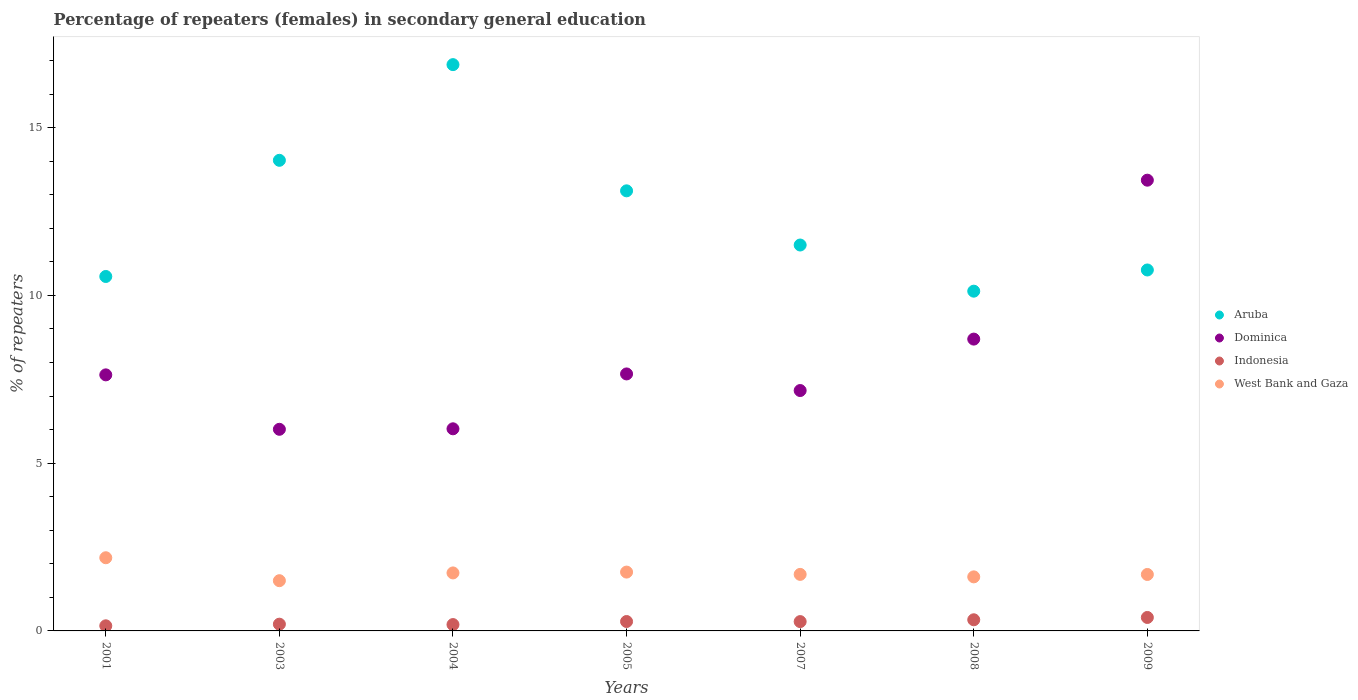Is the number of dotlines equal to the number of legend labels?
Keep it short and to the point. Yes. What is the percentage of female repeaters in West Bank and Gaza in 2001?
Your answer should be very brief. 2.18. Across all years, what is the maximum percentage of female repeaters in Aruba?
Keep it short and to the point. 16.88. Across all years, what is the minimum percentage of female repeaters in Indonesia?
Ensure brevity in your answer.  0.15. In which year was the percentage of female repeaters in West Bank and Gaza maximum?
Provide a succinct answer. 2001. What is the total percentage of female repeaters in Indonesia in the graph?
Give a very brief answer. 1.83. What is the difference between the percentage of female repeaters in Indonesia in 2004 and that in 2009?
Keep it short and to the point. -0.21. What is the difference between the percentage of female repeaters in Indonesia in 2004 and the percentage of female repeaters in Aruba in 2005?
Offer a very short reply. -12.93. What is the average percentage of female repeaters in Dominica per year?
Provide a succinct answer. 8.09. In the year 2009, what is the difference between the percentage of female repeaters in Dominica and percentage of female repeaters in West Bank and Gaza?
Offer a terse response. 11.75. What is the ratio of the percentage of female repeaters in West Bank and Gaza in 2005 to that in 2008?
Ensure brevity in your answer.  1.09. What is the difference between the highest and the second highest percentage of female repeaters in West Bank and Gaza?
Your answer should be compact. 0.43. What is the difference between the highest and the lowest percentage of female repeaters in Indonesia?
Keep it short and to the point. 0.25. Is the sum of the percentage of female repeaters in Indonesia in 2001 and 2003 greater than the maximum percentage of female repeaters in Dominica across all years?
Give a very brief answer. No. Does the percentage of female repeaters in Indonesia monotonically increase over the years?
Provide a succinct answer. No. Is the percentage of female repeaters in Indonesia strictly greater than the percentage of female repeaters in Dominica over the years?
Keep it short and to the point. No. How are the legend labels stacked?
Provide a short and direct response. Vertical. What is the title of the graph?
Your answer should be compact. Percentage of repeaters (females) in secondary general education. What is the label or title of the X-axis?
Keep it short and to the point. Years. What is the label or title of the Y-axis?
Ensure brevity in your answer.  % of repeaters. What is the % of repeaters of Aruba in 2001?
Ensure brevity in your answer.  10.56. What is the % of repeaters in Dominica in 2001?
Offer a very short reply. 7.63. What is the % of repeaters of Indonesia in 2001?
Offer a very short reply. 0.15. What is the % of repeaters of West Bank and Gaza in 2001?
Give a very brief answer. 2.18. What is the % of repeaters of Aruba in 2003?
Your response must be concise. 14.03. What is the % of repeaters in Dominica in 2003?
Provide a succinct answer. 6.01. What is the % of repeaters of Indonesia in 2003?
Give a very brief answer. 0.2. What is the % of repeaters in West Bank and Gaza in 2003?
Your response must be concise. 1.5. What is the % of repeaters of Aruba in 2004?
Make the answer very short. 16.88. What is the % of repeaters of Dominica in 2004?
Provide a succinct answer. 6.02. What is the % of repeaters of Indonesia in 2004?
Offer a very short reply. 0.19. What is the % of repeaters in West Bank and Gaza in 2004?
Ensure brevity in your answer.  1.73. What is the % of repeaters of Aruba in 2005?
Make the answer very short. 13.12. What is the % of repeaters in Dominica in 2005?
Your answer should be compact. 7.66. What is the % of repeaters in Indonesia in 2005?
Make the answer very short. 0.28. What is the % of repeaters of West Bank and Gaza in 2005?
Provide a short and direct response. 1.75. What is the % of repeaters of Aruba in 2007?
Ensure brevity in your answer.  11.5. What is the % of repeaters of Dominica in 2007?
Provide a succinct answer. 7.17. What is the % of repeaters in Indonesia in 2007?
Ensure brevity in your answer.  0.28. What is the % of repeaters in West Bank and Gaza in 2007?
Ensure brevity in your answer.  1.68. What is the % of repeaters in Aruba in 2008?
Provide a succinct answer. 10.13. What is the % of repeaters in Dominica in 2008?
Provide a short and direct response. 8.7. What is the % of repeaters in Indonesia in 2008?
Offer a very short reply. 0.33. What is the % of repeaters in West Bank and Gaza in 2008?
Ensure brevity in your answer.  1.61. What is the % of repeaters of Aruba in 2009?
Ensure brevity in your answer.  10.76. What is the % of repeaters in Dominica in 2009?
Your answer should be very brief. 13.43. What is the % of repeaters of Indonesia in 2009?
Ensure brevity in your answer.  0.4. What is the % of repeaters in West Bank and Gaza in 2009?
Offer a terse response. 1.68. Across all years, what is the maximum % of repeaters in Aruba?
Offer a very short reply. 16.88. Across all years, what is the maximum % of repeaters in Dominica?
Offer a terse response. 13.43. Across all years, what is the maximum % of repeaters in Indonesia?
Ensure brevity in your answer.  0.4. Across all years, what is the maximum % of repeaters in West Bank and Gaza?
Make the answer very short. 2.18. Across all years, what is the minimum % of repeaters of Aruba?
Provide a short and direct response. 10.13. Across all years, what is the minimum % of repeaters in Dominica?
Provide a short and direct response. 6.01. Across all years, what is the minimum % of repeaters in Indonesia?
Your response must be concise. 0.15. Across all years, what is the minimum % of repeaters of West Bank and Gaza?
Provide a short and direct response. 1.5. What is the total % of repeaters in Aruba in the graph?
Provide a succinct answer. 86.98. What is the total % of repeaters of Dominica in the graph?
Ensure brevity in your answer.  56.62. What is the total % of repeaters in Indonesia in the graph?
Ensure brevity in your answer.  1.83. What is the total % of repeaters in West Bank and Gaza in the graph?
Offer a terse response. 12.14. What is the difference between the % of repeaters in Aruba in 2001 and that in 2003?
Make the answer very short. -3.46. What is the difference between the % of repeaters of Dominica in 2001 and that in 2003?
Ensure brevity in your answer.  1.62. What is the difference between the % of repeaters of Indonesia in 2001 and that in 2003?
Keep it short and to the point. -0.05. What is the difference between the % of repeaters in West Bank and Gaza in 2001 and that in 2003?
Ensure brevity in your answer.  0.68. What is the difference between the % of repeaters of Aruba in 2001 and that in 2004?
Your answer should be compact. -6.31. What is the difference between the % of repeaters of Dominica in 2001 and that in 2004?
Your answer should be compact. 1.61. What is the difference between the % of repeaters in Indonesia in 2001 and that in 2004?
Give a very brief answer. -0.04. What is the difference between the % of repeaters of West Bank and Gaza in 2001 and that in 2004?
Your answer should be compact. 0.45. What is the difference between the % of repeaters of Aruba in 2001 and that in 2005?
Ensure brevity in your answer.  -2.55. What is the difference between the % of repeaters in Dominica in 2001 and that in 2005?
Provide a succinct answer. -0.03. What is the difference between the % of repeaters of Indonesia in 2001 and that in 2005?
Make the answer very short. -0.13. What is the difference between the % of repeaters of West Bank and Gaza in 2001 and that in 2005?
Your response must be concise. 0.43. What is the difference between the % of repeaters in Aruba in 2001 and that in 2007?
Your answer should be compact. -0.94. What is the difference between the % of repeaters of Dominica in 2001 and that in 2007?
Ensure brevity in your answer.  0.47. What is the difference between the % of repeaters of Indonesia in 2001 and that in 2007?
Offer a terse response. -0.13. What is the difference between the % of repeaters in West Bank and Gaza in 2001 and that in 2007?
Your answer should be compact. 0.5. What is the difference between the % of repeaters in Aruba in 2001 and that in 2008?
Provide a succinct answer. 0.44. What is the difference between the % of repeaters of Dominica in 2001 and that in 2008?
Offer a terse response. -1.07. What is the difference between the % of repeaters of Indonesia in 2001 and that in 2008?
Offer a terse response. -0.18. What is the difference between the % of repeaters in West Bank and Gaza in 2001 and that in 2008?
Make the answer very short. 0.57. What is the difference between the % of repeaters in Aruba in 2001 and that in 2009?
Keep it short and to the point. -0.19. What is the difference between the % of repeaters of Dominica in 2001 and that in 2009?
Your answer should be compact. -5.8. What is the difference between the % of repeaters in Indonesia in 2001 and that in 2009?
Provide a short and direct response. -0.25. What is the difference between the % of repeaters of West Bank and Gaza in 2001 and that in 2009?
Your response must be concise. 0.5. What is the difference between the % of repeaters of Aruba in 2003 and that in 2004?
Your answer should be compact. -2.85. What is the difference between the % of repeaters in Dominica in 2003 and that in 2004?
Provide a succinct answer. -0.01. What is the difference between the % of repeaters of Indonesia in 2003 and that in 2004?
Ensure brevity in your answer.  0.01. What is the difference between the % of repeaters of West Bank and Gaza in 2003 and that in 2004?
Your answer should be compact. -0.23. What is the difference between the % of repeaters in Aruba in 2003 and that in 2005?
Ensure brevity in your answer.  0.91. What is the difference between the % of repeaters of Dominica in 2003 and that in 2005?
Provide a succinct answer. -1.65. What is the difference between the % of repeaters in Indonesia in 2003 and that in 2005?
Keep it short and to the point. -0.08. What is the difference between the % of repeaters of West Bank and Gaza in 2003 and that in 2005?
Your answer should be compact. -0.26. What is the difference between the % of repeaters in Aruba in 2003 and that in 2007?
Provide a succinct answer. 2.52. What is the difference between the % of repeaters of Dominica in 2003 and that in 2007?
Give a very brief answer. -1.16. What is the difference between the % of repeaters in Indonesia in 2003 and that in 2007?
Your answer should be compact. -0.08. What is the difference between the % of repeaters of West Bank and Gaza in 2003 and that in 2007?
Your answer should be very brief. -0.19. What is the difference between the % of repeaters of Aruba in 2003 and that in 2008?
Make the answer very short. 3.9. What is the difference between the % of repeaters in Dominica in 2003 and that in 2008?
Your response must be concise. -2.69. What is the difference between the % of repeaters in Indonesia in 2003 and that in 2008?
Your answer should be very brief. -0.13. What is the difference between the % of repeaters of West Bank and Gaza in 2003 and that in 2008?
Your answer should be compact. -0.11. What is the difference between the % of repeaters in Aruba in 2003 and that in 2009?
Ensure brevity in your answer.  3.27. What is the difference between the % of repeaters of Dominica in 2003 and that in 2009?
Your answer should be compact. -7.43. What is the difference between the % of repeaters in Indonesia in 2003 and that in 2009?
Offer a very short reply. -0.2. What is the difference between the % of repeaters of West Bank and Gaza in 2003 and that in 2009?
Provide a succinct answer. -0.19. What is the difference between the % of repeaters of Aruba in 2004 and that in 2005?
Make the answer very short. 3.76. What is the difference between the % of repeaters in Dominica in 2004 and that in 2005?
Your response must be concise. -1.64. What is the difference between the % of repeaters in Indonesia in 2004 and that in 2005?
Offer a very short reply. -0.09. What is the difference between the % of repeaters of West Bank and Gaza in 2004 and that in 2005?
Your response must be concise. -0.03. What is the difference between the % of repeaters of Aruba in 2004 and that in 2007?
Your response must be concise. 5.38. What is the difference between the % of repeaters of Dominica in 2004 and that in 2007?
Your response must be concise. -1.14. What is the difference between the % of repeaters of Indonesia in 2004 and that in 2007?
Keep it short and to the point. -0.09. What is the difference between the % of repeaters in West Bank and Gaza in 2004 and that in 2007?
Your answer should be very brief. 0.04. What is the difference between the % of repeaters of Aruba in 2004 and that in 2008?
Your response must be concise. 6.75. What is the difference between the % of repeaters in Dominica in 2004 and that in 2008?
Ensure brevity in your answer.  -2.67. What is the difference between the % of repeaters in Indonesia in 2004 and that in 2008?
Your answer should be very brief. -0.14. What is the difference between the % of repeaters of West Bank and Gaza in 2004 and that in 2008?
Ensure brevity in your answer.  0.12. What is the difference between the % of repeaters in Aruba in 2004 and that in 2009?
Your answer should be very brief. 6.12. What is the difference between the % of repeaters of Dominica in 2004 and that in 2009?
Offer a very short reply. -7.41. What is the difference between the % of repeaters of Indonesia in 2004 and that in 2009?
Offer a very short reply. -0.21. What is the difference between the % of repeaters of West Bank and Gaza in 2004 and that in 2009?
Ensure brevity in your answer.  0.05. What is the difference between the % of repeaters of Aruba in 2005 and that in 2007?
Keep it short and to the point. 1.61. What is the difference between the % of repeaters in Dominica in 2005 and that in 2007?
Offer a terse response. 0.49. What is the difference between the % of repeaters of Indonesia in 2005 and that in 2007?
Offer a terse response. 0. What is the difference between the % of repeaters in West Bank and Gaza in 2005 and that in 2007?
Provide a succinct answer. 0.07. What is the difference between the % of repeaters in Aruba in 2005 and that in 2008?
Provide a short and direct response. 2.99. What is the difference between the % of repeaters of Dominica in 2005 and that in 2008?
Your answer should be compact. -1.04. What is the difference between the % of repeaters of Indonesia in 2005 and that in 2008?
Offer a terse response. -0.05. What is the difference between the % of repeaters of West Bank and Gaza in 2005 and that in 2008?
Make the answer very short. 0.14. What is the difference between the % of repeaters in Aruba in 2005 and that in 2009?
Make the answer very short. 2.36. What is the difference between the % of repeaters of Dominica in 2005 and that in 2009?
Provide a succinct answer. -5.78. What is the difference between the % of repeaters in Indonesia in 2005 and that in 2009?
Provide a short and direct response. -0.12. What is the difference between the % of repeaters in West Bank and Gaza in 2005 and that in 2009?
Give a very brief answer. 0.07. What is the difference between the % of repeaters in Aruba in 2007 and that in 2008?
Your response must be concise. 1.38. What is the difference between the % of repeaters in Dominica in 2007 and that in 2008?
Ensure brevity in your answer.  -1.53. What is the difference between the % of repeaters of Indonesia in 2007 and that in 2008?
Your response must be concise. -0.05. What is the difference between the % of repeaters in West Bank and Gaza in 2007 and that in 2008?
Give a very brief answer. 0.07. What is the difference between the % of repeaters in Aruba in 2007 and that in 2009?
Provide a succinct answer. 0.74. What is the difference between the % of repeaters in Dominica in 2007 and that in 2009?
Make the answer very short. -6.27. What is the difference between the % of repeaters in Indonesia in 2007 and that in 2009?
Give a very brief answer. -0.12. What is the difference between the % of repeaters of West Bank and Gaza in 2007 and that in 2009?
Give a very brief answer. 0. What is the difference between the % of repeaters in Aruba in 2008 and that in 2009?
Give a very brief answer. -0.63. What is the difference between the % of repeaters in Dominica in 2008 and that in 2009?
Your answer should be very brief. -4.74. What is the difference between the % of repeaters of Indonesia in 2008 and that in 2009?
Your answer should be compact. -0.07. What is the difference between the % of repeaters of West Bank and Gaza in 2008 and that in 2009?
Give a very brief answer. -0.07. What is the difference between the % of repeaters in Aruba in 2001 and the % of repeaters in Dominica in 2003?
Offer a terse response. 4.55. What is the difference between the % of repeaters of Aruba in 2001 and the % of repeaters of Indonesia in 2003?
Provide a short and direct response. 10.36. What is the difference between the % of repeaters of Aruba in 2001 and the % of repeaters of West Bank and Gaza in 2003?
Make the answer very short. 9.07. What is the difference between the % of repeaters of Dominica in 2001 and the % of repeaters of Indonesia in 2003?
Your answer should be compact. 7.43. What is the difference between the % of repeaters in Dominica in 2001 and the % of repeaters in West Bank and Gaza in 2003?
Provide a succinct answer. 6.13. What is the difference between the % of repeaters in Indonesia in 2001 and the % of repeaters in West Bank and Gaza in 2003?
Your response must be concise. -1.34. What is the difference between the % of repeaters in Aruba in 2001 and the % of repeaters in Dominica in 2004?
Make the answer very short. 4.54. What is the difference between the % of repeaters of Aruba in 2001 and the % of repeaters of Indonesia in 2004?
Your response must be concise. 10.38. What is the difference between the % of repeaters in Aruba in 2001 and the % of repeaters in West Bank and Gaza in 2004?
Provide a short and direct response. 8.84. What is the difference between the % of repeaters of Dominica in 2001 and the % of repeaters of Indonesia in 2004?
Your answer should be compact. 7.44. What is the difference between the % of repeaters in Dominica in 2001 and the % of repeaters in West Bank and Gaza in 2004?
Make the answer very short. 5.9. What is the difference between the % of repeaters of Indonesia in 2001 and the % of repeaters of West Bank and Gaza in 2004?
Offer a very short reply. -1.58. What is the difference between the % of repeaters of Aruba in 2001 and the % of repeaters of Dominica in 2005?
Your response must be concise. 2.9. What is the difference between the % of repeaters in Aruba in 2001 and the % of repeaters in Indonesia in 2005?
Your answer should be compact. 10.28. What is the difference between the % of repeaters of Aruba in 2001 and the % of repeaters of West Bank and Gaza in 2005?
Ensure brevity in your answer.  8.81. What is the difference between the % of repeaters of Dominica in 2001 and the % of repeaters of Indonesia in 2005?
Your response must be concise. 7.35. What is the difference between the % of repeaters of Dominica in 2001 and the % of repeaters of West Bank and Gaza in 2005?
Ensure brevity in your answer.  5.88. What is the difference between the % of repeaters in Indonesia in 2001 and the % of repeaters in West Bank and Gaza in 2005?
Keep it short and to the point. -1.6. What is the difference between the % of repeaters in Aruba in 2001 and the % of repeaters in Dominica in 2007?
Give a very brief answer. 3.4. What is the difference between the % of repeaters in Aruba in 2001 and the % of repeaters in Indonesia in 2007?
Provide a short and direct response. 10.29. What is the difference between the % of repeaters of Aruba in 2001 and the % of repeaters of West Bank and Gaza in 2007?
Provide a succinct answer. 8.88. What is the difference between the % of repeaters of Dominica in 2001 and the % of repeaters of Indonesia in 2007?
Make the answer very short. 7.35. What is the difference between the % of repeaters of Dominica in 2001 and the % of repeaters of West Bank and Gaza in 2007?
Make the answer very short. 5.95. What is the difference between the % of repeaters of Indonesia in 2001 and the % of repeaters of West Bank and Gaza in 2007?
Make the answer very short. -1.53. What is the difference between the % of repeaters in Aruba in 2001 and the % of repeaters in Dominica in 2008?
Your answer should be compact. 1.87. What is the difference between the % of repeaters in Aruba in 2001 and the % of repeaters in Indonesia in 2008?
Your answer should be compact. 10.23. What is the difference between the % of repeaters of Aruba in 2001 and the % of repeaters of West Bank and Gaza in 2008?
Give a very brief answer. 8.95. What is the difference between the % of repeaters in Dominica in 2001 and the % of repeaters in Indonesia in 2008?
Offer a very short reply. 7.3. What is the difference between the % of repeaters of Dominica in 2001 and the % of repeaters of West Bank and Gaza in 2008?
Ensure brevity in your answer.  6.02. What is the difference between the % of repeaters in Indonesia in 2001 and the % of repeaters in West Bank and Gaza in 2008?
Ensure brevity in your answer.  -1.46. What is the difference between the % of repeaters in Aruba in 2001 and the % of repeaters in Dominica in 2009?
Your answer should be very brief. -2.87. What is the difference between the % of repeaters in Aruba in 2001 and the % of repeaters in Indonesia in 2009?
Your response must be concise. 10.16. What is the difference between the % of repeaters of Aruba in 2001 and the % of repeaters of West Bank and Gaza in 2009?
Provide a succinct answer. 8.88. What is the difference between the % of repeaters of Dominica in 2001 and the % of repeaters of Indonesia in 2009?
Provide a short and direct response. 7.23. What is the difference between the % of repeaters in Dominica in 2001 and the % of repeaters in West Bank and Gaza in 2009?
Offer a terse response. 5.95. What is the difference between the % of repeaters of Indonesia in 2001 and the % of repeaters of West Bank and Gaza in 2009?
Provide a short and direct response. -1.53. What is the difference between the % of repeaters in Aruba in 2003 and the % of repeaters in Dominica in 2004?
Keep it short and to the point. 8. What is the difference between the % of repeaters of Aruba in 2003 and the % of repeaters of Indonesia in 2004?
Offer a very short reply. 13.84. What is the difference between the % of repeaters of Aruba in 2003 and the % of repeaters of West Bank and Gaza in 2004?
Offer a very short reply. 12.3. What is the difference between the % of repeaters in Dominica in 2003 and the % of repeaters in Indonesia in 2004?
Ensure brevity in your answer.  5.82. What is the difference between the % of repeaters of Dominica in 2003 and the % of repeaters of West Bank and Gaza in 2004?
Give a very brief answer. 4.28. What is the difference between the % of repeaters in Indonesia in 2003 and the % of repeaters in West Bank and Gaza in 2004?
Provide a succinct answer. -1.53. What is the difference between the % of repeaters in Aruba in 2003 and the % of repeaters in Dominica in 2005?
Your answer should be very brief. 6.37. What is the difference between the % of repeaters of Aruba in 2003 and the % of repeaters of Indonesia in 2005?
Your answer should be compact. 13.75. What is the difference between the % of repeaters of Aruba in 2003 and the % of repeaters of West Bank and Gaza in 2005?
Ensure brevity in your answer.  12.27. What is the difference between the % of repeaters of Dominica in 2003 and the % of repeaters of Indonesia in 2005?
Make the answer very short. 5.73. What is the difference between the % of repeaters of Dominica in 2003 and the % of repeaters of West Bank and Gaza in 2005?
Give a very brief answer. 4.26. What is the difference between the % of repeaters of Indonesia in 2003 and the % of repeaters of West Bank and Gaza in 2005?
Provide a succinct answer. -1.55. What is the difference between the % of repeaters in Aruba in 2003 and the % of repeaters in Dominica in 2007?
Provide a succinct answer. 6.86. What is the difference between the % of repeaters in Aruba in 2003 and the % of repeaters in Indonesia in 2007?
Offer a very short reply. 13.75. What is the difference between the % of repeaters of Aruba in 2003 and the % of repeaters of West Bank and Gaza in 2007?
Your answer should be compact. 12.34. What is the difference between the % of repeaters in Dominica in 2003 and the % of repeaters in Indonesia in 2007?
Offer a terse response. 5.73. What is the difference between the % of repeaters of Dominica in 2003 and the % of repeaters of West Bank and Gaza in 2007?
Provide a short and direct response. 4.32. What is the difference between the % of repeaters of Indonesia in 2003 and the % of repeaters of West Bank and Gaza in 2007?
Offer a very short reply. -1.48. What is the difference between the % of repeaters of Aruba in 2003 and the % of repeaters of Dominica in 2008?
Ensure brevity in your answer.  5.33. What is the difference between the % of repeaters in Aruba in 2003 and the % of repeaters in Indonesia in 2008?
Give a very brief answer. 13.69. What is the difference between the % of repeaters in Aruba in 2003 and the % of repeaters in West Bank and Gaza in 2008?
Provide a short and direct response. 12.42. What is the difference between the % of repeaters in Dominica in 2003 and the % of repeaters in Indonesia in 2008?
Your response must be concise. 5.68. What is the difference between the % of repeaters in Dominica in 2003 and the % of repeaters in West Bank and Gaza in 2008?
Your response must be concise. 4.4. What is the difference between the % of repeaters of Indonesia in 2003 and the % of repeaters of West Bank and Gaza in 2008?
Provide a short and direct response. -1.41. What is the difference between the % of repeaters of Aruba in 2003 and the % of repeaters of Dominica in 2009?
Ensure brevity in your answer.  0.59. What is the difference between the % of repeaters of Aruba in 2003 and the % of repeaters of Indonesia in 2009?
Your answer should be compact. 13.63. What is the difference between the % of repeaters of Aruba in 2003 and the % of repeaters of West Bank and Gaza in 2009?
Provide a succinct answer. 12.34. What is the difference between the % of repeaters of Dominica in 2003 and the % of repeaters of Indonesia in 2009?
Provide a short and direct response. 5.61. What is the difference between the % of repeaters in Dominica in 2003 and the % of repeaters in West Bank and Gaza in 2009?
Provide a short and direct response. 4.33. What is the difference between the % of repeaters in Indonesia in 2003 and the % of repeaters in West Bank and Gaza in 2009?
Provide a succinct answer. -1.48. What is the difference between the % of repeaters of Aruba in 2004 and the % of repeaters of Dominica in 2005?
Make the answer very short. 9.22. What is the difference between the % of repeaters in Aruba in 2004 and the % of repeaters in Indonesia in 2005?
Offer a terse response. 16.6. What is the difference between the % of repeaters of Aruba in 2004 and the % of repeaters of West Bank and Gaza in 2005?
Offer a very short reply. 15.13. What is the difference between the % of repeaters in Dominica in 2004 and the % of repeaters in Indonesia in 2005?
Ensure brevity in your answer.  5.74. What is the difference between the % of repeaters in Dominica in 2004 and the % of repeaters in West Bank and Gaza in 2005?
Give a very brief answer. 4.27. What is the difference between the % of repeaters in Indonesia in 2004 and the % of repeaters in West Bank and Gaza in 2005?
Provide a short and direct response. -1.56. What is the difference between the % of repeaters of Aruba in 2004 and the % of repeaters of Dominica in 2007?
Provide a succinct answer. 9.71. What is the difference between the % of repeaters of Aruba in 2004 and the % of repeaters of Indonesia in 2007?
Your response must be concise. 16.6. What is the difference between the % of repeaters in Aruba in 2004 and the % of repeaters in West Bank and Gaza in 2007?
Make the answer very short. 15.19. What is the difference between the % of repeaters of Dominica in 2004 and the % of repeaters of Indonesia in 2007?
Provide a succinct answer. 5.75. What is the difference between the % of repeaters of Dominica in 2004 and the % of repeaters of West Bank and Gaza in 2007?
Your answer should be very brief. 4.34. What is the difference between the % of repeaters of Indonesia in 2004 and the % of repeaters of West Bank and Gaza in 2007?
Your answer should be very brief. -1.5. What is the difference between the % of repeaters of Aruba in 2004 and the % of repeaters of Dominica in 2008?
Give a very brief answer. 8.18. What is the difference between the % of repeaters of Aruba in 2004 and the % of repeaters of Indonesia in 2008?
Ensure brevity in your answer.  16.55. What is the difference between the % of repeaters of Aruba in 2004 and the % of repeaters of West Bank and Gaza in 2008?
Your answer should be very brief. 15.27. What is the difference between the % of repeaters in Dominica in 2004 and the % of repeaters in Indonesia in 2008?
Provide a succinct answer. 5.69. What is the difference between the % of repeaters in Dominica in 2004 and the % of repeaters in West Bank and Gaza in 2008?
Make the answer very short. 4.41. What is the difference between the % of repeaters in Indonesia in 2004 and the % of repeaters in West Bank and Gaza in 2008?
Make the answer very short. -1.42. What is the difference between the % of repeaters of Aruba in 2004 and the % of repeaters of Dominica in 2009?
Your answer should be very brief. 3.44. What is the difference between the % of repeaters of Aruba in 2004 and the % of repeaters of Indonesia in 2009?
Make the answer very short. 16.48. What is the difference between the % of repeaters of Aruba in 2004 and the % of repeaters of West Bank and Gaza in 2009?
Your answer should be very brief. 15.2. What is the difference between the % of repeaters in Dominica in 2004 and the % of repeaters in Indonesia in 2009?
Offer a very short reply. 5.62. What is the difference between the % of repeaters of Dominica in 2004 and the % of repeaters of West Bank and Gaza in 2009?
Ensure brevity in your answer.  4.34. What is the difference between the % of repeaters in Indonesia in 2004 and the % of repeaters in West Bank and Gaza in 2009?
Your answer should be compact. -1.49. What is the difference between the % of repeaters of Aruba in 2005 and the % of repeaters of Dominica in 2007?
Your answer should be compact. 5.95. What is the difference between the % of repeaters of Aruba in 2005 and the % of repeaters of Indonesia in 2007?
Ensure brevity in your answer.  12.84. What is the difference between the % of repeaters in Aruba in 2005 and the % of repeaters in West Bank and Gaza in 2007?
Make the answer very short. 11.43. What is the difference between the % of repeaters in Dominica in 2005 and the % of repeaters in Indonesia in 2007?
Your answer should be compact. 7.38. What is the difference between the % of repeaters in Dominica in 2005 and the % of repeaters in West Bank and Gaza in 2007?
Keep it short and to the point. 5.97. What is the difference between the % of repeaters of Indonesia in 2005 and the % of repeaters of West Bank and Gaza in 2007?
Keep it short and to the point. -1.4. What is the difference between the % of repeaters of Aruba in 2005 and the % of repeaters of Dominica in 2008?
Ensure brevity in your answer.  4.42. What is the difference between the % of repeaters in Aruba in 2005 and the % of repeaters in Indonesia in 2008?
Offer a very short reply. 12.79. What is the difference between the % of repeaters of Aruba in 2005 and the % of repeaters of West Bank and Gaza in 2008?
Ensure brevity in your answer.  11.51. What is the difference between the % of repeaters in Dominica in 2005 and the % of repeaters in Indonesia in 2008?
Give a very brief answer. 7.33. What is the difference between the % of repeaters in Dominica in 2005 and the % of repeaters in West Bank and Gaza in 2008?
Make the answer very short. 6.05. What is the difference between the % of repeaters in Indonesia in 2005 and the % of repeaters in West Bank and Gaza in 2008?
Give a very brief answer. -1.33. What is the difference between the % of repeaters in Aruba in 2005 and the % of repeaters in Dominica in 2009?
Give a very brief answer. -0.32. What is the difference between the % of repeaters in Aruba in 2005 and the % of repeaters in Indonesia in 2009?
Give a very brief answer. 12.72. What is the difference between the % of repeaters of Aruba in 2005 and the % of repeaters of West Bank and Gaza in 2009?
Provide a short and direct response. 11.43. What is the difference between the % of repeaters in Dominica in 2005 and the % of repeaters in Indonesia in 2009?
Offer a terse response. 7.26. What is the difference between the % of repeaters in Dominica in 2005 and the % of repeaters in West Bank and Gaza in 2009?
Provide a short and direct response. 5.98. What is the difference between the % of repeaters of Indonesia in 2005 and the % of repeaters of West Bank and Gaza in 2009?
Your answer should be compact. -1.4. What is the difference between the % of repeaters of Aruba in 2007 and the % of repeaters of Dominica in 2008?
Provide a succinct answer. 2.8. What is the difference between the % of repeaters of Aruba in 2007 and the % of repeaters of Indonesia in 2008?
Your answer should be very brief. 11.17. What is the difference between the % of repeaters in Aruba in 2007 and the % of repeaters in West Bank and Gaza in 2008?
Keep it short and to the point. 9.89. What is the difference between the % of repeaters of Dominica in 2007 and the % of repeaters of Indonesia in 2008?
Offer a very short reply. 6.83. What is the difference between the % of repeaters in Dominica in 2007 and the % of repeaters in West Bank and Gaza in 2008?
Your answer should be compact. 5.55. What is the difference between the % of repeaters in Indonesia in 2007 and the % of repeaters in West Bank and Gaza in 2008?
Your answer should be very brief. -1.33. What is the difference between the % of repeaters of Aruba in 2007 and the % of repeaters of Dominica in 2009?
Give a very brief answer. -1.93. What is the difference between the % of repeaters of Aruba in 2007 and the % of repeaters of Indonesia in 2009?
Ensure brevity in your answer.  11.1. What is the difference between the % of repeaters in Aruba in 2007 and the % of repeaters in West Bank and Gaza in 2009?
Offer a terse response. 9.82. What is the difference between the % of repeaters of Dominica in 2007 and the % of repeaters of Indonesia in 2009?
Give a very brief answer. 6.76. What is the difference between the % of repeaters in Dominica in 2007 and the % of repeaters in West Bank and Gaza in 2009?
Make the answer very short. 5.48. What is the difference between the % of repeaters of Indonesia in 2007 and the % of repeaters of West Bank and Gaza in 2009?
Make the answer very short. -1.4. What is the difference between the % of repeaters in Aruba in 2008 and the % of repeaters in Dominica in 2009?
Your response must be concise. -3.31. What is the difference between the % of repeaters in Aruba in 2008 and the % of repeaters in Indonesia in 2009?
Offer a terse response. 9.73. What is the difference between the % of repeaters of Aruba in 2008 and the % of repeaters of West Bank and Gaza in 2009?
Your answer should be compact. 8.44. What is the difference between the % of repeaters in Dominica in 2008 and the % of repeaters in Indonesia in 2009?
Your answer should be compact. 8.3. What is the difference between the % of repeaters of Dominica in 2008 and the % of repeaters of West Bank and Gaza in 2009?
Give a very brief answer. 7.02. What is the difference between the % of repeaters in Indonesia in 2008 and the % of repeaters in West Bank and Gaza in 2009?
Give a very brief answer. -1.35. What is the average % of repeaters of Aruba per year?
Provide a short and direct response. 12.43. What is the average % of repeaters of Dominica per year?
Offer a terse response. 8.09. What is the average % of repeaters in Indonesia per year?
Your answer should be very brief. 0.26. What is the average % of repeaters in West Bank and Gaza per year?
Offer a very short reply. 1.73. In the year 2001, what is the difference between the % of repeaters of Aruba and % of repeaters of Dominica?
Offer a terse response. 2.93. In the year 2001, what is the difference between the % of repeaters in Aruba and % of repeaters in Indonesia?
Provide a short and direct response. 10.41. In the year 2001, what is the difference between the % of repeaters of Aruba and % of repeaters of West Bank and Gaza?
Ensure brevity in your answer.  8.38. In the year 2001, what is the difference between the % of repeaters in Dominica and % of repeaters in Indonesia?
Offer a very short reply. 7.48. In the year 2001, what is the difference between the % of repeaters in Dominica and % of repeaters in West Bank and Gaza?
Offer a very short reply. 5.45. In the year 2001, what is the difference between the % of repeaters in Indonesia and % of repeaters in West Bank and Gaza?
Offer a terse response. -2.03. In the year 2003, what is the difference between the % of repeaters of Aruba and % of repeaters of Dominica?
Make the answer very short. 8.02. In the year 2003, what is the difference between the % of repeaters in Aruba and % of repeaters in Indonesia?
Provide a short and direct response. 13.83. In the year 2003, what is the difference between the % of repeaters of Aruba and % of repeaters of West Bank and Gaza?
Offer a terse response. 12.53. In the year 2003, what is the difference between the % of repeaters in Dominica and % of repeaters in Indonesia?
Your answer should be compact. 5.81. In the year 2003, what is the difference between the % of repeaters in Dominica and % of repeaters in West Bank and Gaza?
Keep it short and to the point. 4.51. In the year 2003, what is the difference between the % of repeaters in Indonesia and % of repeaters in West Bank and Gaza?
Offer a very short reply. -1.3. In the year 2004, what is the difference between the % of repeaters in Aruba and % of repeaters in Dominica?
Your answer should be very brief. 10.85. In the year 2004, what is the difference between the % of repeaters of Aruba and % of repeaters of Indonesia?
Ensure brevity in your answer.  16.69. In the year 2004, what is the difference between the % of repeaters of Aruba and % of repeaters of West Bank and Gaza?
Offer a very short reply. 15.15. In the year 2004, what is the difference between the % of repeaters of Dominica and % of repeaters of Indonesia?
Provide a succinct answer. 5.84. In the year 2004, what is the difference between the % of repeaters of Dominica and % of repeaters of West Bank and Gaza?
Provide a succinct answer. 4.3. In the year 2004, what is the difference between the % of repeaters in Indonesia and % of repeaters in West Bank and Gaza?
Your answer should be very brief. -1.54. In the year 2005, what is the difference between the % of repeaters of Aruba and % of repeaters of Dominica?
Offer a very short reply. 5.46. In the year 2005, what is the difference between the % of repeaters of Aruba and % of repeaters of Indonesia?
Offer a terse response. 12.84. In the year 2005, what is the difference between the % of repeaters in Aruba and % of repeaters in West Bank and Gaza?
Your answer should be compact. 11.36. In the year 2005, what is the difference between the % of repeaters of Dominica and % of repeaters of Indonesia?
Provide a short and direct response. 7.38. In the year 2005, what is the difference between the % of repeaters of Dominica and % of repeaters of West Bank and Gaza?
Keep it short and to the point. 5.91. In the year 2005, what is the difference between the % of repeaters in Indonesia and % of repeaters in West Bank and Gaza?
Give a very brief answer. -1.47. In the year 2007, what is the difference between the % of repeaters of Aruba and % of repeaters of Dominica?
Give a very brief answer. 4.34. In the year 2007, what is the difference between the % of repeaters in Aruba and % of repeaters in Indonesia?
Keep it short and to the point. 11.22. In the year 2007, what is the difference between the % of repeaters of Aruba and % of repeaters of West Bank and Gaza?
Offer a very short reply. 9.82. In the year 2007, what is the difference between the % of repeaters of Dominica and % of repeaters of Indonesia?
Provide a succinct answer. 6.89. In the year 2007, what is the difference between the % of repeaters of Dominica and % of repeaters of West Bank and Gaza?
Provide a succinct answer. 5.48. In the year 2007, what is the difference between the % of repeaters of Indonesia and % of repeaters of West Bank and Gaza?
Offer a very short reply. -1.41. In the year 2008, what is the difference between the % of repeaters of Aruba and % of repeaters of Dominica?
Give a very brief answer. 1.43. In the year 2008, what is the difference between the % of repeaters of Aruba and % of repeaters of Indonesia?
Provide a short and direct response. 9.79. In the year 2008, what is the difference between the % of repeaters of Aruba and % of repeaters of West Bank and Gaza?
Offer a very short reply. 8.52. In the year 2008, what is the difference between the % of repeaters in Dominica and % of repeaters in Indonesia?
Offer a terse response. 8.37. In the year 2008, what is the difference between the % of repeaters of Dominica and % of repeaters of West Bank and Gaza?
Provide a short and direct response. 7.09. In the year 2008, what is the difference between the % of repeaters in Indonesia and % of repeaters in West Bank and Gaza?
Make the answer very short. -1.28. In the year 2009, what is the difference between the % of repeaters of Aruba and % of repeaters of Dominica?
Your answer should be compact. -2.68. In the year 2009, what is the difference between the % of repeaters of Aruba and % of repeaters of Indonesia?
Offer a terse response. 10.36. In the year 2009, what is the difference between the % of repeaters in Aruba and % of repeaters in West Bank and Gaza?
Offer a terse response. 9.08. In the year 2009, what is the difference between the % of repeaters in Dominica and % of repeaters in Indonesia?
Your answer should be very brief. 13.03. In the year 2009, what is the difference between the % of repeaters in Dominica and % of repeaters in West Bank and Gaza?
Your answer should be very brief. 11.75. In the year 2009, what is the difference between the % of repeaters in Indonesia and % of repeaters in West Bank and Gaza?
Give a very brief answer. -1.28. What is the ratio of the % of repeaters of Aruba in 2001 to that in 2003?
Keep it short and to the point. 0.75. What is the ratio of the % of repeaters in Dominica in 2001 to that in 2003?
Offer a terse response. 1.27. What is the ratio of the % of repeaters in Indonesia in 2001 to that in 2003?
Provide a succinct answer. 0.76. What is the ratio of the % of repeaters in West Bank and Gaza in 2001 to that in 2003?
Your answer should be compact. 1.46. What is the ratio of the % of repeaters of Aruba in 2001 to that in 2004?
Your response must be concise. 0.63. What is the ratio of the % of repeaters in Dominica in 2001 to that in 2004?
Offer a terse response. 1.27. What is the ratio of the % of repeaters in Indonesia in 2001 to that in 2004?
Your response must be concise. 0.81. What is the ratio of the % of repeaters of West Bank and Gaza in 2001 to that in 2004?
Your answer should be very brief. 1.26. What is the ratio of the % of repeaters of Aruba in 2001 to that in 2005?
Your answer should be compact. 0.81. What is the ratio of the % of repeaters in Indonesia in 2001 to that in 2005?
Provide a short and direct response. 0.54. What is the ratio of the % of repeaters in West Bank and Gaza in 2001 to that in 2005?
Ensure brevity in your answer.  1.24. What is the ratio of the % of repeaters of Aruba in 2001 to that in 2007?
Give a very brief answer. 0.92. What is the ratio of the % of repeaters in Dominica in 2001 to that in 2007?
Provide a short and direct response. 1.07. What is the ratio of the % of repeaters in Indonesia in 2001 to that in 2007?
Offer a terse response. 0.55. What is the ratio of the % of repeaters in West Bank and Gaza in 2001 to that in 2007?
Your answer should be compact. 1.29. What is the ratio of the % of repeaters in Aruba in 2001 to that in 2008?
Give a very brief answer. 1.04. What is the ratio of the % of repeaters of Dominica in 2001 to that in 2008?
Keep it short and to the point. 0.88. What is the ratio of the % of repeaters of Indonesia in 2001 to that in 2008?
Make the answer very short. 0.46. What is the ratio of the % of repeaters of West Bank and Gaza in 2001 to that in 2008?
Ensure brevity in your answer.  1.35. What is the ratio of the % of repeaters in Dominica in 2001 to that in 2009?
Ensure brevity in your answer.  0.57. What is the ratio of the % of repeaters of Indonesia in 2001 to that in 2009?
Ensure brevity in your answer.  0.38. What is the ratio of the % of repeaters in West Bank and Gaza in 2001 to that in 2009?
Offer a very short reply. 1.3. What is the ratio of the % of repeaters in Aruba in 2003 to that in 2004?
Offer a very short reply. 0.83. What is the ratio of the % of repeaters of Dominica in 2003 to that in 2004?
Make the answer very short. 1. What is the ratio of the % of repeaters of Indonesia in 2003 to that in 2004?
Keep it short and to the point. 1.06. What is the ratio of the % of repeaters of West Bank and Gaza in 2003 to that in 2004?
Offer a terse response. 0.87. What is the ratio of the % of repeaters in Aruba in 2003 to that in 2005?
Your response must be concise. 1.07. What is the ratio of the % of repeaters of Dominica in 2003 to that in 2005?
Offer a very short reply. 0.78. What is the ratio of the % of repeaters of Indonesia in 2003 to that in 2005?
Provide a succinct answer. 0.72. What is the ratio of the % of repeaters in West Bank and Gaza in 2003 to that in 2005?
Ensure brevity in your answer.  0.85. What is the ratio of the % of repeaters of Aruba in 2003 to that in 2007?
Keep it short and to the point. 1.22. What is the ratio of the % of repeaters of Dominica in 2003 to that in 2007?
Provide a short and direct response. 0.84. What is the ratio of the % of repeaters in Indonesia in 2003 to that in 2007?
Make the answer very short. 0.72. What is the ratio of the % of repeaters in West Bank and Gaza in 2003 to that in 2007?
Offer a terse response. 0.89. What is the ratio of the % of repeaters in Aruba in 2003 to that in 2008?
Offer a terse response. 1.39. What is the ratio of the % of repeaters in Dominica in 2003 to that in 2008?
Provide a succinct answer. 0.69. What is the ratio of the % of repeaters in Indonesia in 2003 to that in 2008?
Offer a terse response. 0.61. What is the ratio of the % of repeaters in West Bank and Gaza in 2003 to that in 2008?
Provide a succinct answer. 0.93. What is the ratio of the % of repeaters of Aruba in 2003 to that in 2009?
Provide a succinct answer. 1.3. What is the ratio of the % of repeaters in Dominica in 2003 to that in 2009?
Offer a terse response. 0.45. What is the ratio of the % of repeaters in Indonesia in 2003 to that in 2009?
Give a very brief answer. 0.5. What is the ratio of the % of repeaters in West Bank and Gaza in 2003 to that in 2009?
Offer a terse response. 0.89. What is the ratio of the % of repeaters of Aruba in 2004 to that in 2005?
Your answer should be compact. 1.29. What is the ratio of the % of repeaters in Dominica in 2004 to that in 2005?
Provide a short and direct response. 0.79. What is the ratio of the % of repeaters of Indonesia in 2004 to that in 2005?
Your answer should be very brief. 0.67. What is the ratio of the % of repeaters in West Bank and Gaza in 2004 to that in 2005?
Offer a terse response. 0.99. What is the ratio of the % of repeaters of Aruba in 2004 to that in 2007?
Keep it short and to the point. 1.47. What is the ratio of the % of repeaters of Dominica in 2004 to that in 2007?
Provide a short and direct response. 0.84. What is the ratio of the % of repeaters of Indonesia in 2004 to that in 2007?
Provide a succinct answer. 0.68. What is the ratio of the % of repeaters of West Bank and Gaza in 2004 to that in 2007?
Give a very brief answer. 1.03. What is the ratio of the % of repeaters of Aruba in 2004 to that in 2008?
Your answer should be compact. 1.67. What is the ratio of the % of repeaters of Dominica in 2004 to that in 2008?
Provide a succinct answer. 0.69. What is the ratio of the % of repeaters in Indonesia in 2004 to that in 2008?
Ensure brevity in your answer.  0.57. What is the ratio of the % of repeaters of West Bank and Gaza in 2004 to that in 2008?
Keep it short and to the point. 1.07. What is the ratio of the % of repeaters of Aruba in 2004 to that in 2009?
Keep it short and to the point. 1.57. What is the ratio of the % of repeaters in Dominica in 2004 to that in 2009?
Provide a short and direct response. 0.45. What is the ratio of the % of repeaters of Indonesia in 2004 to that in 2009?
Your answer should be compact. 0.47. What is the ratio of the % of repeaters in West Bank and Gaza in 2004 to that in 2009?
Your response must be concise. 1.03. What is the ratio of the % of repeaters of Aruba in 2005 to that in 2007?
Your response must be concise. 1.14. What is the ratio of the % of repeaters in Dominica in 2005 to that in 2007?
Offer a terse response. 1.07. What is the ratio of the % of repeaters in Indonesia in 2005 to that in 2007?
Ensure brevity in your answer.  1.01. What is the ratio of the % of repeaters in West Bank and Gaza in 2005 to that in 2007?
Provide a succinct answer. 1.04. What is the ratio of the % of repeaters of Aruba in 2005 to that in 2008?
Your response must be concise. 1.3. What is the ratio of the % of repeaters in Dominica in 2005 to that in 2008?
Give a very brief answer. 0.88. What is the ratio of the % of repeaters in Indonesia in 2005 to that in 2008?
Your answer should be very brief. 0.84. What is the ratio of the % of repeaters in West Bank and Gaza in 2005 to that in 2008?
Your response must be concise. 1.09. What is the ratio of the % of repeaters in Aruba in 2005 to that in 2009?
Keep it short and to the point. 1.22. What is the ratio of the % of repeaters of Dominica in 2005 to that in 2009?
Ensure brevity in your answer.  0.57. What is the ratio of the % of repeaters of Indonesia in 2005 to that in 2009?
Ensure brevity in your answer.  0.7. What is the ratio of the % of repeaters of West Bank and Gaza in 2005 to that in 2009?
Give a very brief answer. 1.04. What is the ratio of the % of repeaters of Aruba in 2007 to that in 2008?
Provide a short and direct response. 1.14. What is the ratio of the % of repeaters of Dominica in 2007 to that in 2008?
Your answer should be very brief. 0.82. What is the ratio of the % of repeaters of Indonesia in 2007 to that in 2008?
Your answer should be very brief. 0.84. What is the ratio of the % of repeaters in West Bank and Gaza in 2007 to that in 2008?
Offer a terse response. 1.05. What is the ratio of the % of repeaters in Aruba in 2007 to that in 2009?
Your answer should be compact. 1.07. What is the ratio of the % of repeaters in Dominica in 2007 to that in 2009?
Your response must be concise. 0.53. What is the ratio of the % of repeaters of Indonesia in 2007 to that in 2009?
Give a very brief answer. 0.69. What is the ratio of the % of repeaters of Aruba in 2008 to that in 2009?
Give a very brief answer. 0.94. What is the ratio of the % of repeaters in Dominica in 2008 to that in 2009?
Your answer should be very brief. 0.65. What is the ratio of the % of repeaters of Indonesia in 2008 to that in 2009?
Your answer should be compact. 0.83. What is the ratio of the % of repeaters in West Bank and Gaza in 2008 to that in 2009?
Your response must be concise. 0.96. What is the difference between the highest and the second highest % of repeaters in Aruba?
Your response must be concise. 2.85. What is the difference between the highest and the second highest % of repeaters of Dominica?
Make the answer very short. 4.74. What is the difference between the highest and the second highest % of repeaters of Indonesia?
Offer a very short reply. 0.07. What is the difference between the highest and the second highest % of repeaters of West Bank and Gaza?
Provide a short and direct response. 0.43. What is the difference between the highest and the lowest % of repeaters in Aruba?
Give a very brief answer. 6.75. What is the difference between the highest and the lowest % of repeaters of Dominica?
Offer a terse response. 7.43. What is the difference between the highest and the lowest % of repeaters of Indonesia?
Ensure brevity in your answer.  0.25. What is the difference between the highest and the lowest % of repeaters in West Bank and Gaza?
Your answer should be very brief. 0.68. 